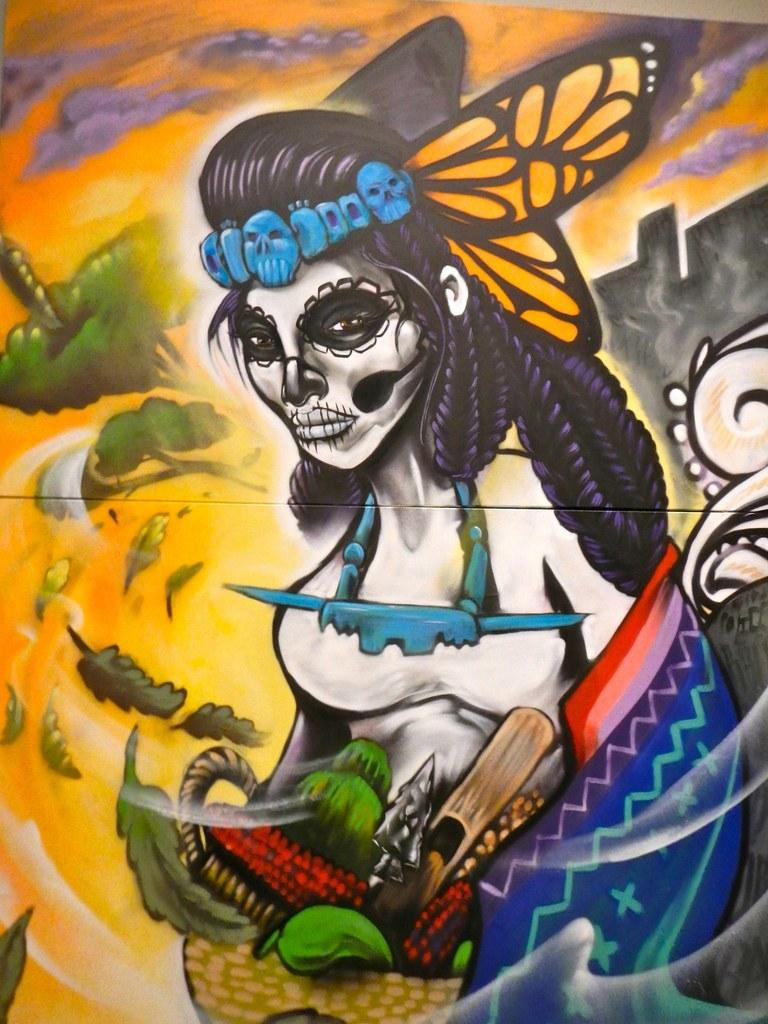What is depicted on the poster in the image? The poster contains a drawing of a witch woman. What is the witch woman holding in the image? The witch woman is holding a basket. What can be found inside the basket? There is a red color tool in the basket. What color is the background of the poster? The background of the poster is yellow. What type of vegetation is present in the background? Green leaves are present in the background. Can you tell me how many toys are on the floor in the image? There are no toys present in the image; it features a poster with a drawing of a witch woman. Is the father of the witch woman visible in the image? There is no person, including a father, present in the image; it only features a poster with a drawing of a witch woman. 